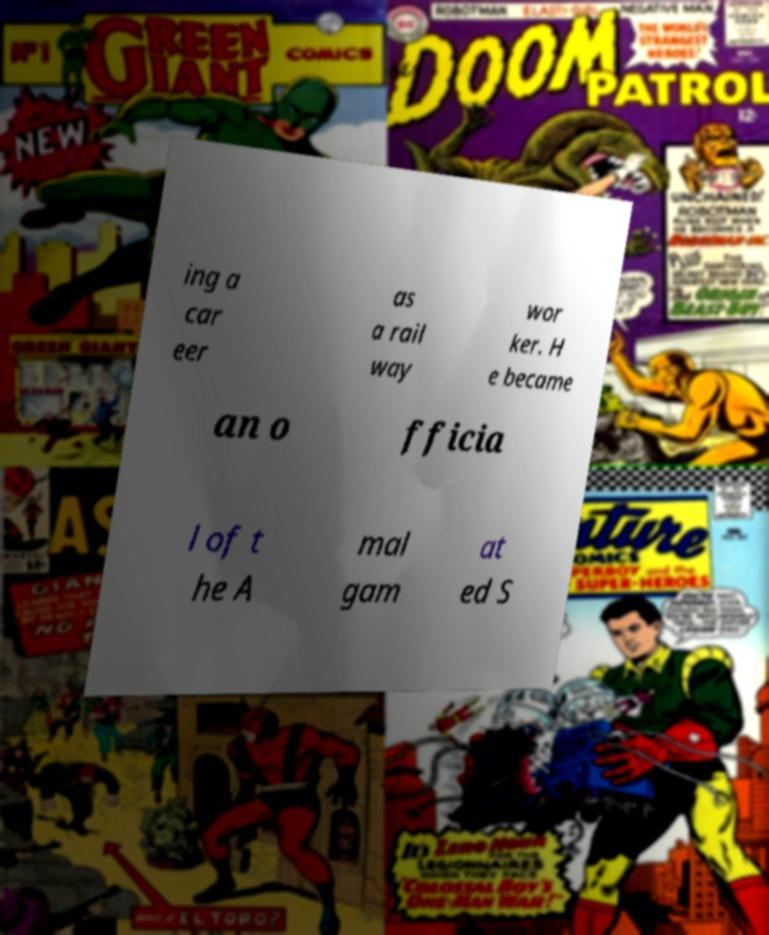Could you assist in decoding the text presented in this image and type it out clearly? ing a car eer as a rail way wor ker. H e became an o fficia l of t he A mal gam at ed S 